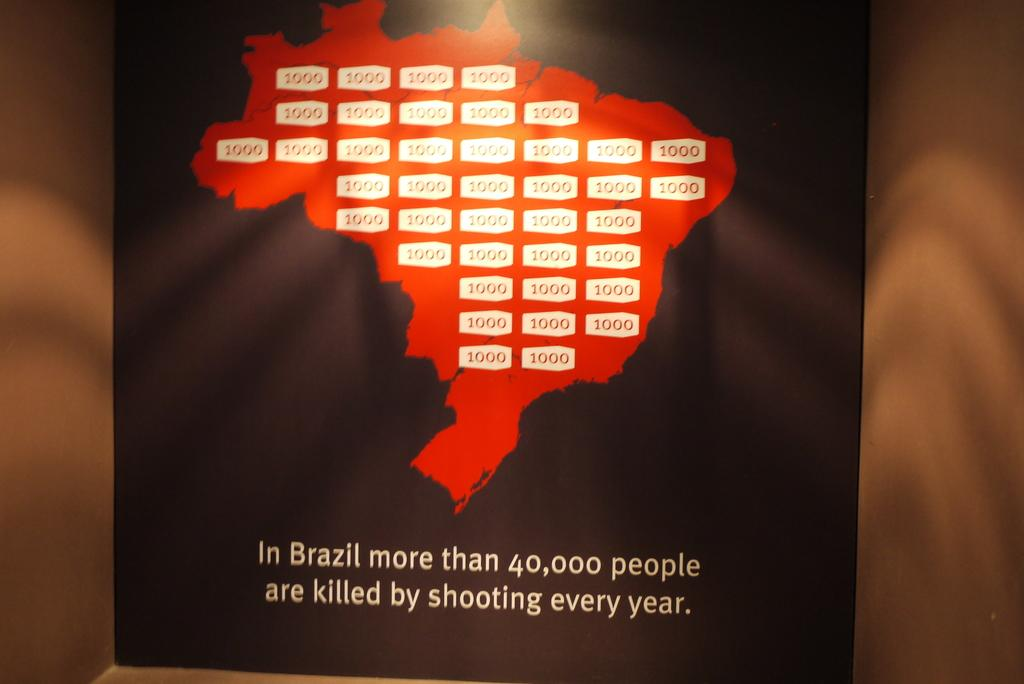<image>
Relay a brief, clear account of the picture shown. A map of Brazil with the message that there are more than 40,000 people killed by shooting in Brazil every year. 